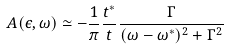<formula> <loc_0><loc_0><loc_500><loc_500>A ( \epsilon , \omega ) \simeq - \frac { 1 } { \pi } \frac { t ^ { * } } { t } \frac { \Gamma } { ( \omega - \omega ^ { * } ) ^ { 2 } + \Gamma ^ { 2 } }</formula> 